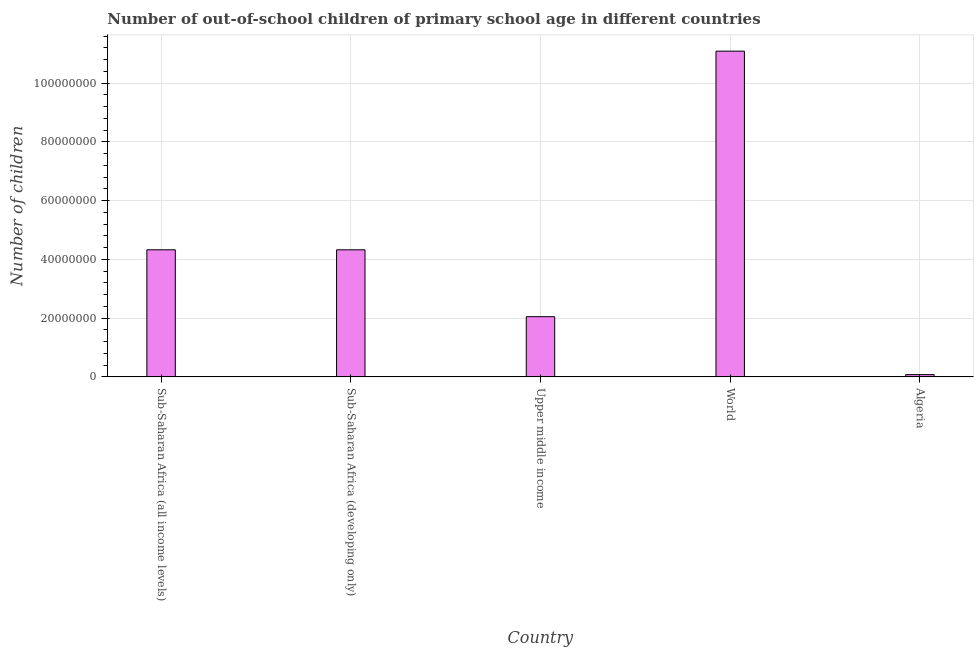Does the graph contain any zero values?
Your answer should be compact. No. What is the title of the graph?
Your answer should be compact. Number of out-of-school children of primary school age in different countries. What is the label or title of the Y-axis?
Ensure brevity in your answer.  Number of children. What is the number of out-of-school children in World?
Provide a short and direct response. 1.11e+08. Across all countries, what is the maximum number of out-of-school children?
Provide a short and direct response. 1.11e+08. Across all countries, what is the minimum number of out-of-school children?
Keep it short and to the point. 7.69e+05. In which country was the number of out-of-school children maximum?
Provide a succinct answer. World. In which country was the number of out-of-school children minimum?
Provide a short and direct response. Algeria. What is the sum of the number of out-of-school children?
Give a very brief answer. 2.19e+08. What is the difference between the number of out-of-school children in Sub-Saharan Africa (developing only) and Upper middle income?
Provide a succinct answer. 2.28e+07. What is the average number of out-of-school children per country?
Keep it short and to the point. 4.37e+07. What is the median number of out-of-school children?
Provide a succinct answer. 4.32e+07. What is the ratio of the number of out-of-school children in Sub-Saharan Africa (all income levels) to that in World?
Your answer should be compact. 0.39. Is the difference between the number of out-of-school children in Algeria and World greater than the difference between any two countries?
Provide a short and direct response. Yes. What is the difference between the highest and the second highest number of out-of-school children?
Your answer should be compact. 6.76e+07. What is the difference between the highest and the lowest number of out-of-school children?
Give a very brief answer. 1.10e+08. In how many countries, is the number of out-of-school children greater than the average number of out-of-school children taken over all countries?
Offer a very short reply. 1. How many bars are there?
Keep it short and to the point. 5. Are all the bars in the graph horizontal?
Offer a terse response. No. What is the difference between two consecutive major ticks on the Y-axis?
Ensure brevity in your answer.  2.00e+07. Are the values on the major ticks of Y-axis written in scientific E-notation?
Keep it short and to the point. No. What is the Number of children in Sub-Saharan Africa (all income levels)?
Provide a short and direct response. 4.33e+07. What is the Number of children of Sub-Saharan Africa (developing only)?
Give a very brief answer. 4.32e+07. What is the Number of children of Upper middle income?
Make the answer very short. 2.05e+07. What is the Number of children in World?
Ensure brevity in your answer.  1.11e+08. What is the Number of children of Algeria?
Offer a terse response. 7.69e+05. What is the difference between the Number of children in Sub-Saharan Africa (all income levels) and Sub-Saharan Africa (developing only)?
Your response must be concise. 1.01e+04. What is the difference between the Number of children in Sub-Saharan Africa (all income levels) and Upper middle income?
Provide a short and direct response. 2.28e+07. What is the difference between the Number of children in Sub-Saharan Africa (all income levels) and World?
Make the answer very short. -6.76e+07. What is the difference between the Number of children in Sub-Saharan Africa (all income levels) and Algeria?
Your answer should be compact. 4.25e+07. What is the difference between the Number of children in Sub-Saharan Africa (developing only) and Upper middle income?
Offer a very short reply. 2.28e+07. What is the difference between the Number of children in Sub-Saharan Africa (developing only) and World?
Your answer should be compact. -6.76e+07. What is the difference between the Number of children in Sub-Saharan Africa (developing only) and Algeria?
Keep it short and to the point. 4.25e+07. What is the difference between the Number of children in Upper middle income and World?
Ensure brevity in your answer.  -9.04e+07. What is the difference between the Number of children in Upper middle income and Algeria?
Offer a very short reply. 1.97e+07. What is the difference between the Number of children in World and Algeria?
Ensure brevity in your answer.  1.10e+08. What is the ratio of the Number of children in Sub-Saharan Africa (all income levels) to that in Upper middle income?
Ensure brevity in your answer.  2.11. What is the ratio of the Number of children in Sub-Saharan Africa (all income levels) to that in World?
Make the answer very short. 0.39. What is the ratio of the Number of children in Sub-Saharan Africa (all income levels) to that in Algeria?
Your answer should be very brief. 56.27. What is the ratio of the Number of children in Sub-Saharan Africa (developing only) to that in Upper middle income?
Your response must be concise. 2.11. What is the ratio of the Number of children in Sub-Saharan Africa (developing only) to that in World?
Your answer should be very brief. 0.39. What is the ratio of the Number of children in Sub-Saharan Africa (developing only) to that in Algeria?
Your answer should be very brief. 56.26. What is the ratio of the Number of children in Upper middle income to that in World?
Ensure brevity in your answer.  0.18. What is the ratio of the Number of children in Upper middle income to that in Algeria?
Offer a terse response. 26.64. What is the ratio of the Number of children in World to that in Algeria?
Provide a short and direct response. 144.21. 